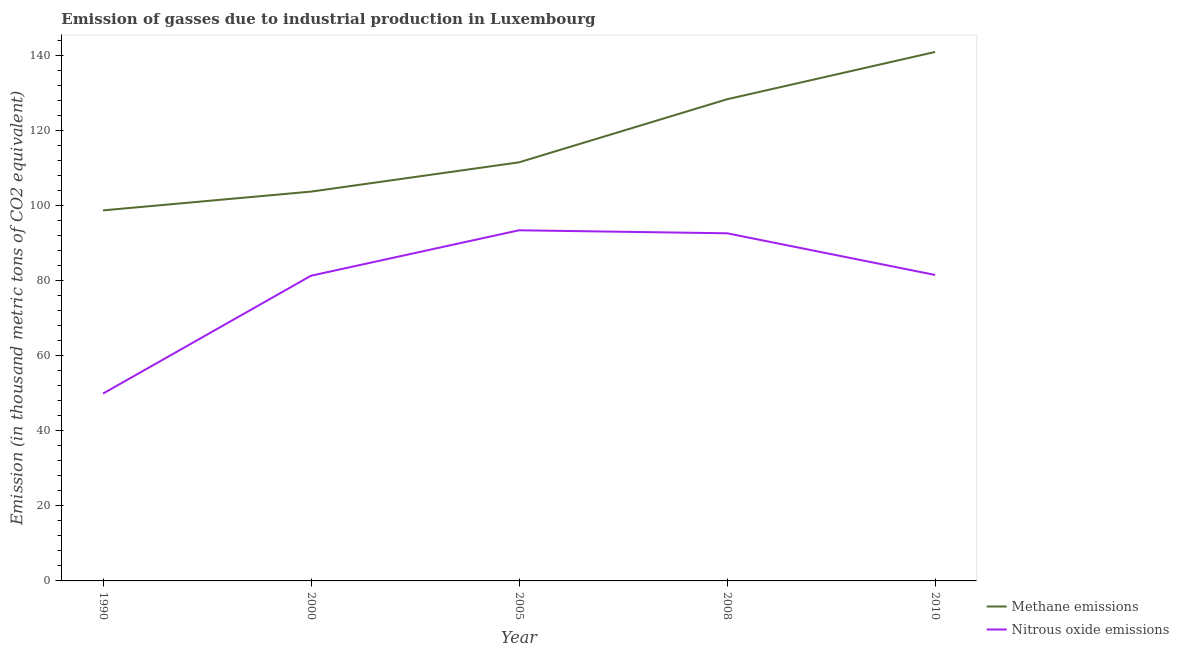Does the line corresponding to amount of methane emissions intersect with the line corresponding to amount of nitrous oxide emissions?
Give a very brief answer. No. Is the number of lines equal to the number of legend labels?
Ensure brevity in your answer.  Yes. What is the amount of methane emissions in 2008?
Your answer should be very brief. 128.3. Across all years, what is the maximum amount of nitrous oxide emissions?
Ensure brevity in your answer.  93.4. Across all years, what is the minimum amount of methane emissions?
Your answer should be compact. 98.7. What is the total amount of nitrous oxide emissions in the graph?
Ensure brevity in your answer.  398.7. What is the difference between the amount of methane emissions in 2000 and that in 2010?
Your response must be concise. -37.2. What is the difference between the amount of methane emissions in 2010 and the amount of nitrous oxide emissions in 2000?
Give a very brief answer. 59.6. What is the average amount of nitrous oxide emissions per year?
Your answer should be very brief. 79.74. In the year 2005, what is the difference between the amount of nitrous oxide emissions and amount of methane emissions?
Offer a very short reply. -18.1. What is the ratio of the amount of methane emissions in 1990 to that in 2005?
Your answer should be compact. 0.89. Is the difference between the amount of nitrous oxide emissions in 1990 and 2010 greater than the difference between the amount of methane emissions in 1990 and 2010?
Provide a succinct answer. Yes. What is the difference between the highest and the second highest amount of methane emissions?
Offer a terse response. 12.6. What is the difference between the highest and the lowest amount of nitrous oxide emissions?
Your response must be concise. 43.5. In how many years, is the amount of nitrous oxide emissions greater than the average amount of nitrous oxide emissions taken over all years?
Your answer should be very brief. 4. Is the sum of the amount of methane emissions in 1990 and 2005 greater than the maximum amount of nitrous oxide emissions across all years?
Keep it short and to the point. Yes. Does the amount of methane emissions monotonically increase over the years?
Give a very brief answer. Yes. How many lines are there?
Provide a short and direct response. 2. What is the difference between two consecutive major ticks on the Y-axis?
Make the answer very short. 20. Does the graph contain any zero values?
Provide a succinct answer. No. Where does the legend appear in the graph?
Ensure brevity in your answer.  Bottom right. What is the title of the graph?
Your answer should be compact. Emission of gasses due to industrial production in Luxembourg. Does "Automatic Teller Machines" appear as one of the legend labels in the graph?
Make the answer very short. No. What is the label or title of the Y-axis?
Give a very brief answer. Emission (in thousand metric tons of CO2 equivalent). What is the Emission (in thousand metric tons of CO2 equivalent) of Methane emissions in 1990?
Give a very brief answer. 98.7. What is the Emission (in thousand metric tons of CO2 equivalent) of Nitrous oxide emissions in 1990?
Your answer should be compact. 49.9. What is the Emission (in thousand metric tons of CO2 equivalent) of Methane emissions in 2000?
Your answer should be very brief. 103.7. What is the Emission (in thousand metric tons of CO2 equivalent) in Nitrous oxide emissions in 2000?
Provide a succinct answer. 81.3. What is the Emission (in thousand metric tons of CO2 equivalent) in Methane emissions in 2005?
Keep it short and to the point. 111.5. What is the Emission (in thousand metric tons of CO2 equivalent) of Nitrous oxide emissions in 2005?
Provide a succinct answer. 93.4. What is the Emission (in thousand metric tons of CO2 equivalent) of Methane emissions in 2008?
Give a very brief answer. 128.3. What is the Emission (in thousand metric tons of CO2 equivalent) of Nitrous oxide emissions in 2008?
Give a very brief answer. 92.6. What is the Emission (in thousand metric tons of CO2 equivalent) of Methane emissions in 2010?
Ensure brevity in your answer.  140.9. What is the Emission (in thousand metric tons of CO2 equivalent) of Nitrous oxide emissions in 2010?
Provide a succinct answer. 81.5. Across all years, what is the maximum Emission (in thousand metric tons of CO2 equivalent) in Methane emissions?
Provide a short and direct response. 140.9. Across all years, what is the maximum Emission (in thousand metric tons of CO2 equivalent) of Nitrous oxide emissions?
Your answer should be compact. 93.4. Across all years, what is the minimum Emission (in thousand metric tons of CO2 equivalent) in Methane emissions?
Provide a succinct answer. 98.7. Across all years, what is the minimum Emission (in thousand metric tons of CO2 equivalent) in Nitrous oxide emissions?
Your answer should be compact. 49.9. What is the total Emission (in thousand metric tons of CO2 equivalent) in Methane emissions in the graph?
Make the answer very short. 583.1. What is the total Emission (in thousand metric tons of CO2 equivalent) in Nitrous oxide emissions in the graph?
Offer a very short reply. 398.7. What is the difference between the Emission (in thousand metric tons of CO2 equivalent) in Methane emissions in 1990 and that in 2000?
Provide a succinct answer. -5. What is the difference between the Emission (in thousand metric tons of CO2 equivalent) of Nitrous oxide emissions in 1990 and that in 2000?
Give a very brief answer. -31.4. What is the difference between the Emission (in thousand metric tons of CO2 equivalent) of Methane emissions in 1990 and that in 2005?
Keep it short and to the point. -12.8. What is the difference between the Emission (in thousand metric tons of CO2 equivalent) in Nitrous oxide emissions in 1990 and that in 2005?
Give a very brief answer. -43.5. What is the difference between the Emission (in thousand metric tons of CO2 equivalent) in Methane emissions in 1990 and that in 2008?
Offer a very short reply. -29.6. What is the difference between the Emission (in thousand metric tons of CO2 equivalent) of Nitrous oxide emissions in 1990 and that in 2008?
Offer a terse response. -42.7. What is the difference between the Emission (in thousand metric tons of CO2 equivalent) of Methane emissions in 1990 and that in 2010?
Offer a terse response. -42.2. What is the difference between the Emission (in thousand metric tons of CO2 equivalent) in Nitrous oxide emissions in 1990 and that in 2010?
Ensure brevity in your answer.  -31.6. What is the difference between the Emission (in thousand metric tons of CO2 equivalent) of Methane emissions in 2000 and that in 2005?
Make the answer very short. -7.8. What is the difference between the Emission (in thousand metric tons of CO2 equivalent) in Methane emissions in 2000 and that in 2008?
Ensure brevity in your answer.  -24.6. What is the difference between the Emission (in thousand metric tons of CO2 equivalent) in Methane emissions in 2000 and that in 2010?
Give a very brief answer. -37.2. What is the difference between the Emission (in thousand metric tons of CO2 equivalent) in Nitrous oxide emissions in 2000 and that in 2010?
Your answer should be very brief. -0.2. What is the difference between the Emission (in thousand metric tons of CO2 equivalent) in Methane emissions in 2005 and that in 2008?
Offer a very short reply. -16.8. What is the difference between the Emission (in thousand metric tons of CO2 equivalent) in Nitrous oxide emissions in 2005 and that in 2008?
Offer a very short reply. 0.8. What is the difference between the Emission (in thousand metric tons of CO2 equivalent) in Methane emissions in 2005 and that in 2010?
Your answer should be very brief. -29.4. What is the difference between the Emission (in thousand metric tons of CO2 equivalent) in Methane emissions in 1990 and the Emission (in thousand metric tons of CO2 equivalent) in Nitrous oxide emissions in 2005?
Your response must be concise. 5.3. What is the difference between the Emission (in thousand metric tons of CO2 equivalent) of Methane emissions in 1990 and the Emission (in thousand metric tons of CO2 equivalent) of Nitrous oxide emissions in 2008?
Your response must be concise. 6.1. What is the difference between the Emission (in thousand metric tons of CO2 equivalent) in Methane emissions in 1990 and the Emission (in thousand metric tons of CO2 equivalent) in Nitrous oxide emissions in 2010?
Offer a terse response. 17.2. What is the difference between the Emission (in thousand metric tons of CO2 equivalent) of Methane emissions in 2000 and the Emission (in thousand metric tons of CO2 equivalent) of Nitrous oxide emissions in 2008?
Offer a very short reply. 11.1. What is the difference between the Emission (in thousand metric tons of CO2 equivalent) in Methane emissions in 2000 and the Emission (in thousand metric tons of CO2 equivalent) in Nitrous oxide emissions in 2010?
Your answer should be very brief. 22.2. What is the difference between the Emission (in thousand metric tons of CO2 equivalent) of Methane emissions in 2005 and the Emission (in thousand metric tons of CO2 equivalent) of Nitrous oxide emissions in 2008?
Make the answer very short. 18.9. What is the difference between the Emission (in thousand metric tons of CO2 equivalent) of Methane emissions in 2005 and the Emission (in thousand metric tons of CO2 equivalent) of Nitrous oxide emissions in 2010?
Provide a succinct answer. 30. What is the difference between the Emission (in thousand metric tons of CO2 equivalent) of Methane emissions in 2008 and the Emission (in thousand metric tons of CO2 equivalent) of Nitrous oxide emissions in 2010?
Your answer should be very brief. 46.8. What is the average Emission (in thousand metric tons of CO2 equivalent) in Methane emissions per year?
Give a very brief answer. 116.62. What is the average Emission (in thousand metric tons of CO2 equivalent) of Nitrous oxide emissions per year?
Provide a short and direct response. 79.74. In the year 1990, what is the difference between the Emission (in thousand metric tons of CO2 equivalent) in Methane emissions and Emission (in thousand metric tons of CO2 equivalent) in Nitrous oxide emissions?
Your response must be concise. 48.8. In the year 2000, what is the difference between the Emission (in thousand metric tons of CO2 equivalent) of Methane emissions and Emission (in thousand metric tons of CO2 equivalent) of Nitrous oxide emissions?
Offer a terse response. 22.4. In the year 2005, what is the difference between the Emission (in thousand metric tons of CO2 equivalent) of Methane emissions and Emission (in thousand metric tons of CO2 equivalent) of Nitrous oxide emissions?
Give a very brief answer. 18.1. In the year 2008, what is the difference between the Emission (in thousand metric tons of CO2 equivalent) of Methane emissions and Emission (in thousand metric tons of CO2 equivalent) of Nitrous oxide emissions?
Your answer should be compact. 35.7. In the year 2010, what is the difference between the Emission (in thousand metric tons of CO2 equivalent) in Methane emissions and Emission (in thousand metric tons of CO2 equivalent) in Nitrous oxide emissions?
Your answer should be very brief. 59.4. What is the ratio of the Emission (in thousand metric tons of CO2 equivalent) in Methane emissions in 1990 to that in 2000?
Your answer should be compact. 0.95. What is the ratio of the Emission (in thousand metric tons of CO2 equivalent) of Nitrous oxide emissions in 1990 to that in 2000?
Your answer should be very brief. 0.61. What is the ratio of the Emission (in thousand metric tons of CO2 equivalent) in Methane emissions in 1990 to that in 2005?
Your response must be concise. 0.89. What is the ratio of the Emission (in thousand metric tons of CO2 equivalent) of Nitrous oxide emissions in 1990 to that in 2005?
Your response must be concise. 0.53. What is the ratio of the Emission (in thousand metric tons of CO2 equivalent) of Methane emissions in 1990 to that in 2008?
Offer a terse response. 0.77. What is the ratio of the Emission (in thousand metric tons of CO2 equivalent) in Nitrous oxide emissions in 1990 to that in 2008?
Offer a very short reply. 0.54. What is the ratio of the Emission (in thousand metric tons of CO2 equivalent) in Methane emissions in 1990 to that in 2010?
Ensure brevity in your answer.  0.7. What is the ratio of the Emission (in thousand metric tons of CO2 equivalent) in Nitrous oxide emissions in 1990 to that in 2010?
Your answer should be compact. 0.61. What is the ratio of the Emission (in thousand metric tons of CO2 equivalent) in Methane emissions in 2000 to that in 2005?
Keep it short and to the point. 0.93. What is the ratio of the Emission (in thousand metric tons of CO2 equivalent) of Nitrous oxide emissions in 2000 to that in 2005?
Your answer should be compact. 0.87. What is the ratio of the Emission (in thousand metric tons of CO2 equivalent) in Methane emissions in 2000 to that in 2008?
Ensure brevity in your answer.  0.81. What is the ratio of the Emission (in thousand metric tons of CO2 equivalent) in Nitrous oxide emissions in 2000 to that in 2008?
Keep it short and to the point. 0.88. What is the ratio of the Emission (in thousand metric tons of CO2 equivalent) of Methane emissions in 2000 to that in 2010?
Offer a terse response. 0.74. What is the ratio of the Emission (in thousand metric tons of CO2 equivalent) in Methane emissions in 2005 to that in 2008?
Offer a terse response. 0.87. What is the ratio of the Emission (in thousand metric tons of CO2 equivalent) in Nitrous oxide emissions in 2005 to that in 2008?
Your answer should be very brief. 1.01. What is the ratio of the Emission (in thousand metric tons of CO2 equivalent) of Methane emissions in 2005 to that in 2010?
Your answer should be very brief. 0.79. What is the ratio of the Emission (in thousand metric tons of CO2 equivalent) of Nitrous oxide emissions in 2005 to that in 2010?
Provide a short and direct response. 1.15. What is the ratio of the Emission (in thousand metric tons of CO2 equivalent) of Methane emissions in 2008 to that in 2010?
Your answer should be very brief. 0.91. What is the ratio of the Emission (in thousand metric tons of CO2 equivalent) of Nitrous oxide emissions in 2008 to that in 2010?
Provide a succinct answer. 1.14. What is the difference between the highest and the lowest Emission (in thousand metric tons of CO2 equivalent) in Methane emissions?
Offer a terse response. 42.2. What is the difference between the highest and the lowest Emission (in thousand metric tons of CO2 equivalent) in Nitrous oxide emissions?
Keep it short and to the point. 43.5. 